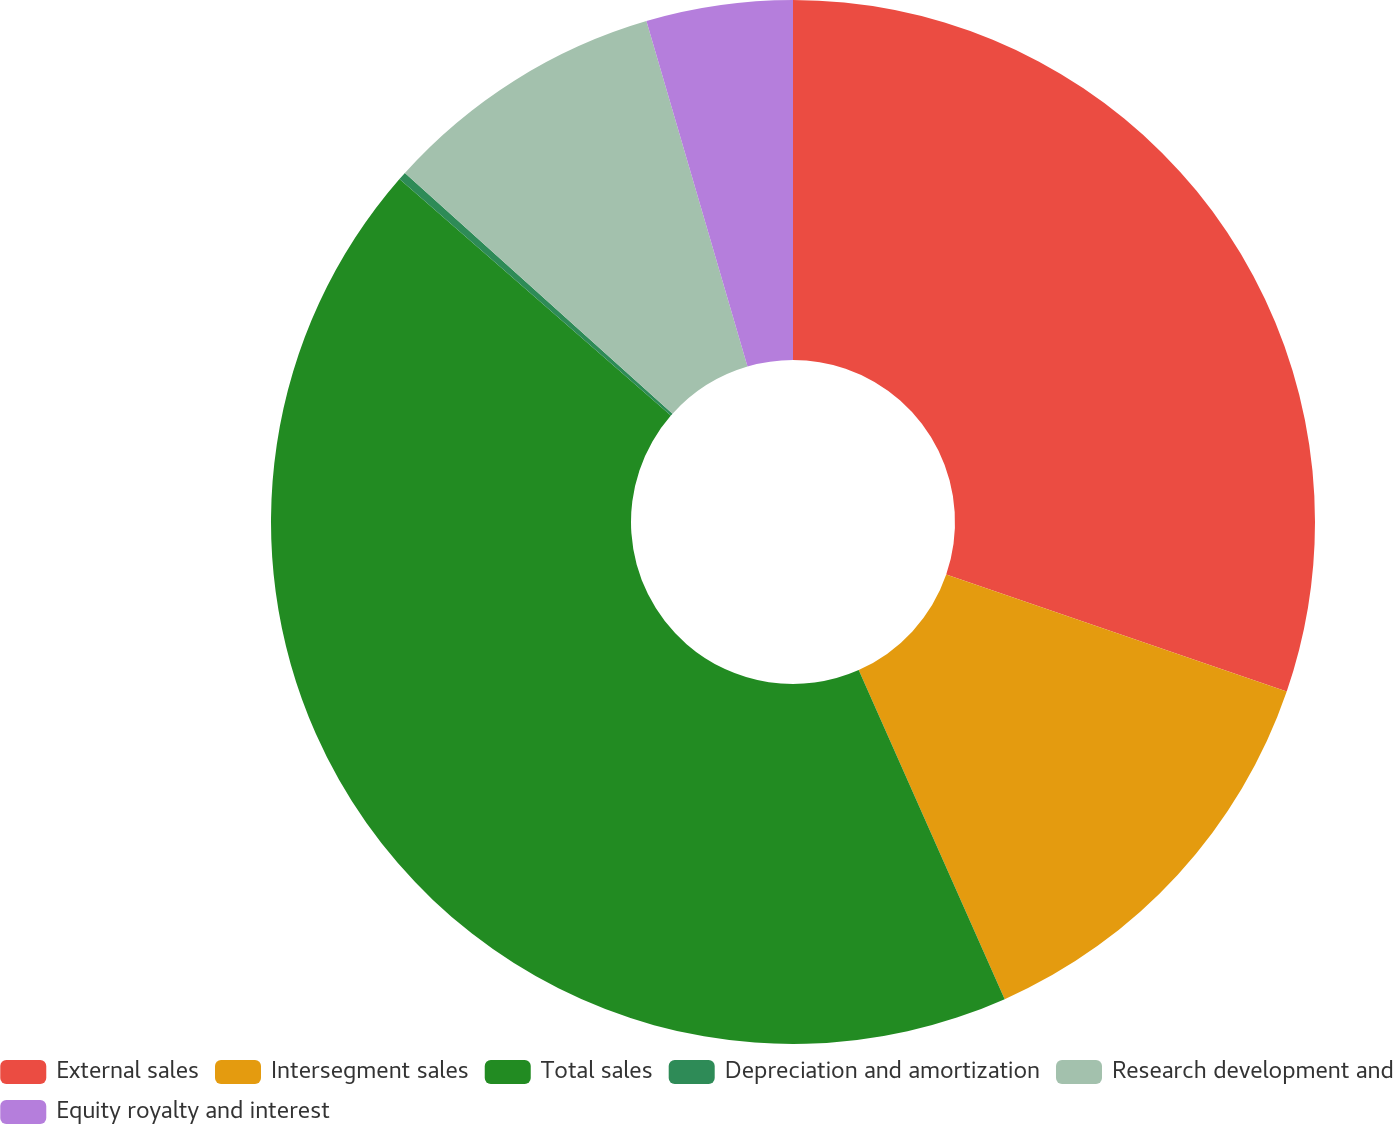<chart> <loc_0><loc_0><loc_500><loc_500><pie_chart><fcel>External sales<fcel>Intersegment sales<fcel>Total sales<fcel>Depreciation and amortization<fcel>Research development and<fcel>Equity royalty and interest<nl><fcel>30.26%<fcel>13.09%<fcel>43.05%<fcel>0.25%<fcel>8.81%<fcel>4.53%<nl></chart> 